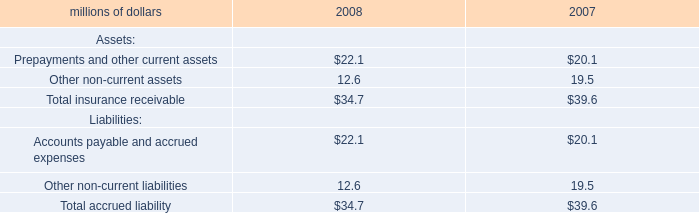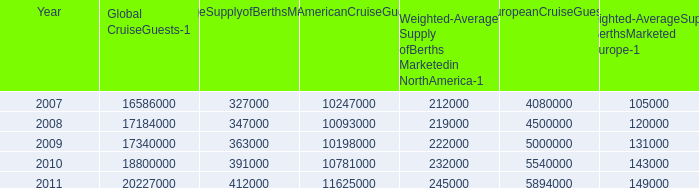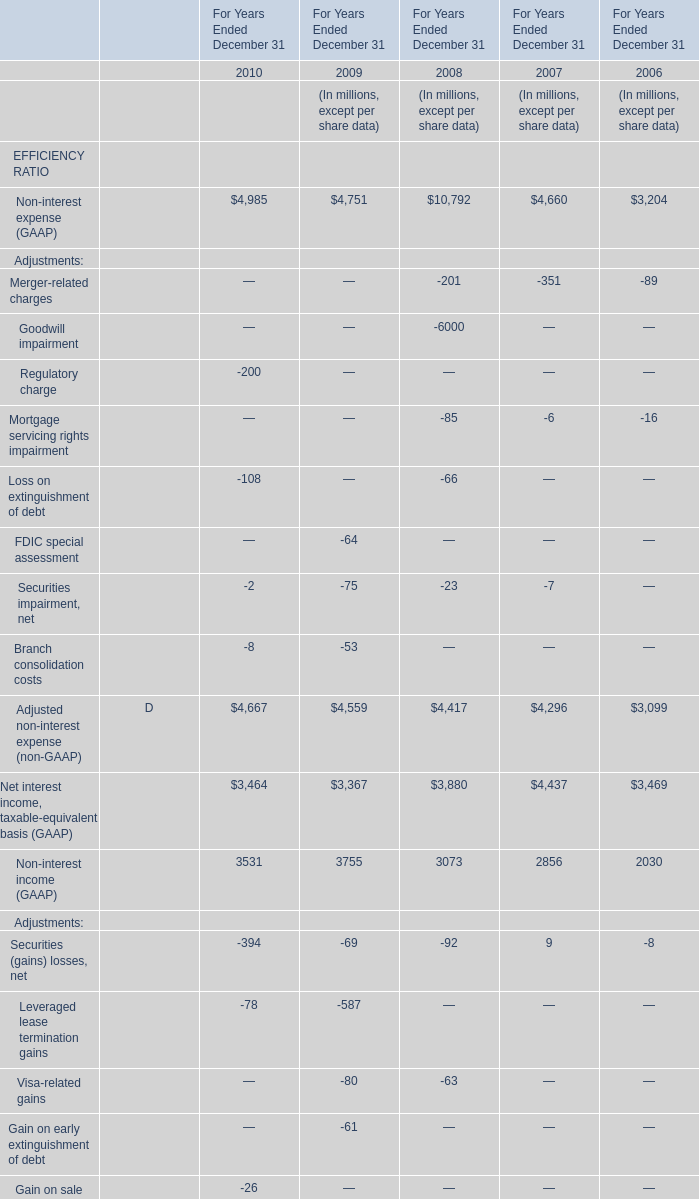what was the total percentage increase from 2007 to 2011 in the number of berths? 
Computations: (((155000 - 100000) / 100000) * 100)
Answer: 55.0. 